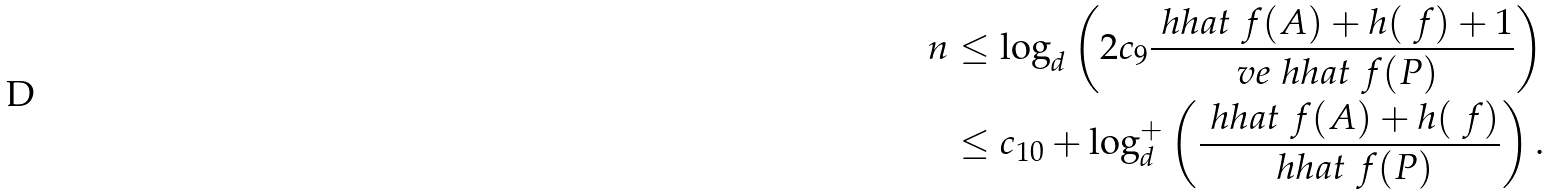<formula> <loc_0><loc_0><loc_500><loc_500>n & \leq \log _ { d } \left ( 2 c _ { 9 } \frac { \ h h a t _ { \ } f ( A ) + h ( \ f ) + 1 } { \ v e \ h h a t _ { \ } f ( P ) } \right ) \\ & \leq c _ { 1 0 } + \log _ { d } ^ { + } \left ( \frac { \ h h a t _ { \ } f ( A ) + h ( \ f ) } { \ h h a t _ { \ } f ( P ) } \right ) .</formula> 